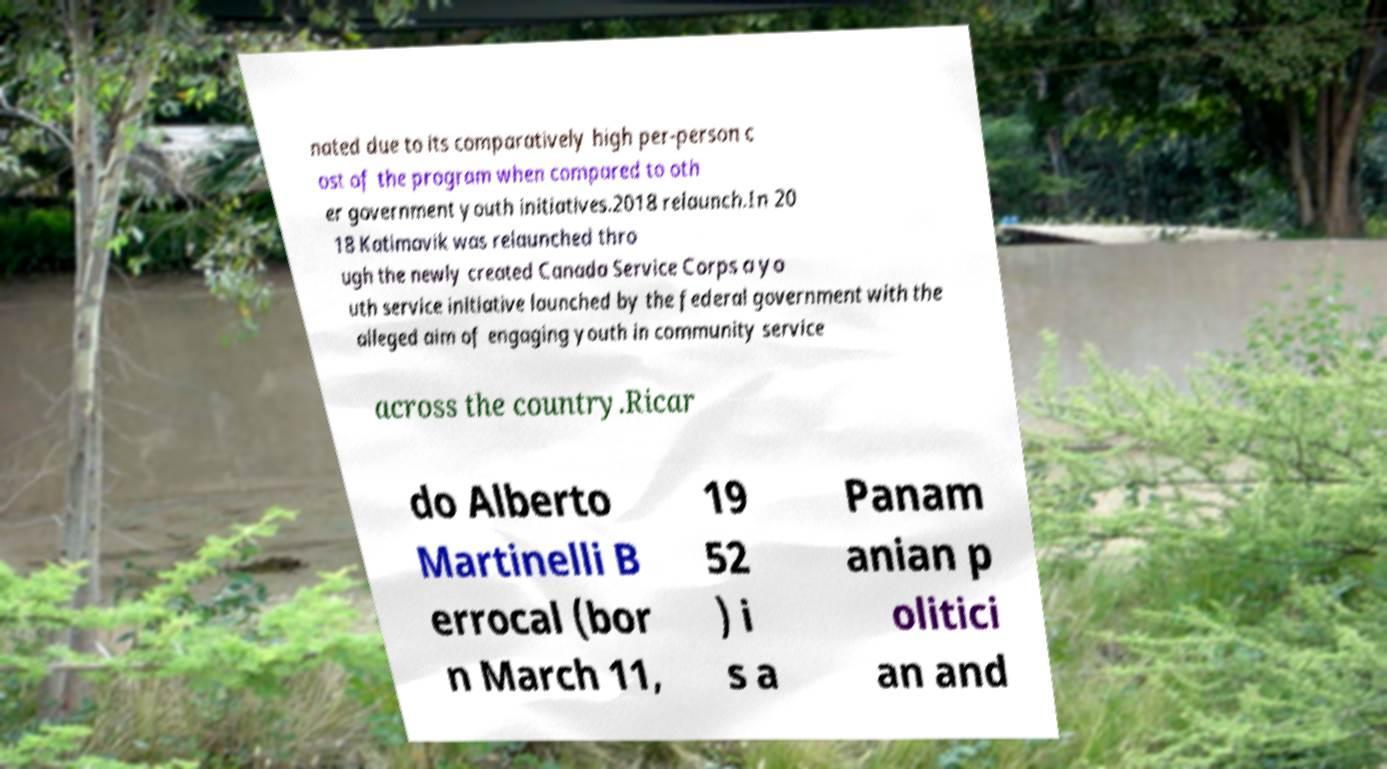For documentation purposes, I need the text within this image transcribed. Could you provide that? nated due to its comparatively high per-person c ost of the program when compared to oth er government youth initiatives.2018 relaunch.In 20 18 Katimavik was relaunched thro ugh the newly created Canada Service Corps a yo uth service initiative launched by the federal government with the alleged aim of engaging youth in community service across the country.Ricar do Alberto Martinelli B errocal (bor n March 11, 19 52 ) i s a Panam anian p olitici an and 